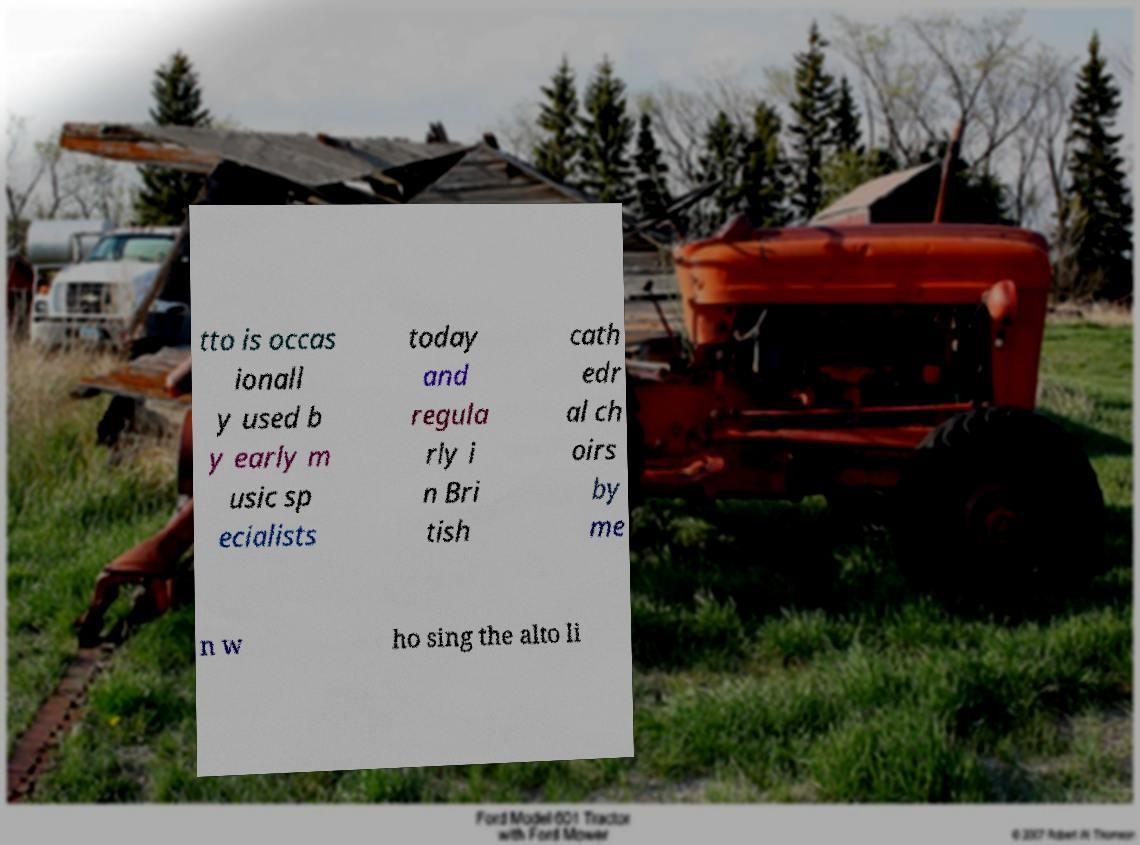Please identify and transcribe the text found in this image. tto is occas ionall y used b y early m usic sp ecialists today and regula rly i n Bri tish cath edr al ch oirs by me n w ho sing the alto li 